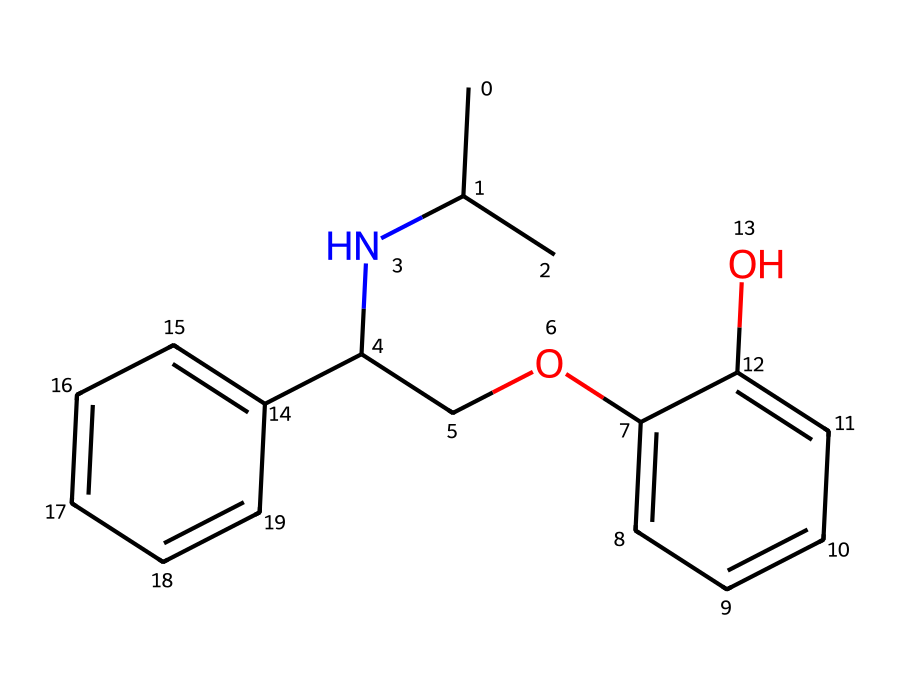what is the primary functional group in this chemical? The chemical structure contains a hydroxyl group (-OH), which can be identified at the aromatic ring. This functional group is indicative of its reactivity and solubility properties.
Answer: hydroxyl how many rings are present in this chemical structure? Analyzing the chemical structure, there are two distinct aromatic rings visible in the compound. Each ring consists of alternating double bonds, contributing to its aromatic nature.
Answer: two what type of drug does this SMILES represent? The presence of an amine group (the nitrogen atom) along with a structure that suggests it may modulate cardiovascular responses indicates that this chemical is a beta-blocker used for anxiety and performance issues.
Answer: beta-blocker how many carbon atoms are in this chemical? By counting the carbon symbols in the structure, there are a total of 16 carbon atoms indicated in the SMILES representation. This includes those in the side chains and rings.
Answer: 16 what effect could this drug have on a performer's anxiety during a concert? Beta-blockers, like the one represented here, work primarily to reduce physiological symptoms of anxiety (such as heart rate and blood pressure), which can help musicians perform more comfortably under pressure.
Answer: reduce anxiety 